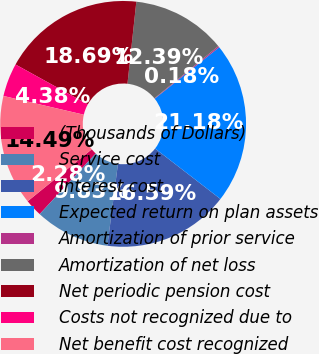Convert chart. <chart><loc_0><loc_0><loc_500><loc_500><pie_chart><fcel>(Thousands of Dollars)<fcel>Service cost<fcel>Interest cost<fcel>Expected return on plan assets<fcel>Amortization of prior service<fcel>Amortization of net loss<fcel>Net periodic pension cost<fcel>Costs not recognized due to<fcel>Net benefit cost recognized<nl><fcel>2.28%<fcel>9.83%<fcel>16.59%<fcel>21.18%<fcel>0.18%<fcel>12.39%<fcel>18.69%<fcel>4.38%<fcel>14.49%<nl></chart> 